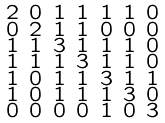Convert formula to latex. <formula><loc_0><loc_0><loc_500><loc_500>\begin{smallmatrix} 2 & 0 & 1 & 1 & 1 & 1 & 0 \\ 0 & 2 & 1 & 1 & 0 & 0 & 0 \\ 1 & 1 & 3 & 1 & 1 & 1 & 0 \\ 1 & 1 & 1 & 3 & 1 & 1 & 0 \\ 1 & 0 & 1 & 1 & 3 & 1 & 1 \\ 1 & 0 & 1 & 1 & 1 & 3 & 0 \\ 0 & 0 & 0 & 0 & 1 & 0 & 3 \end{smallmatrix}</formula> 